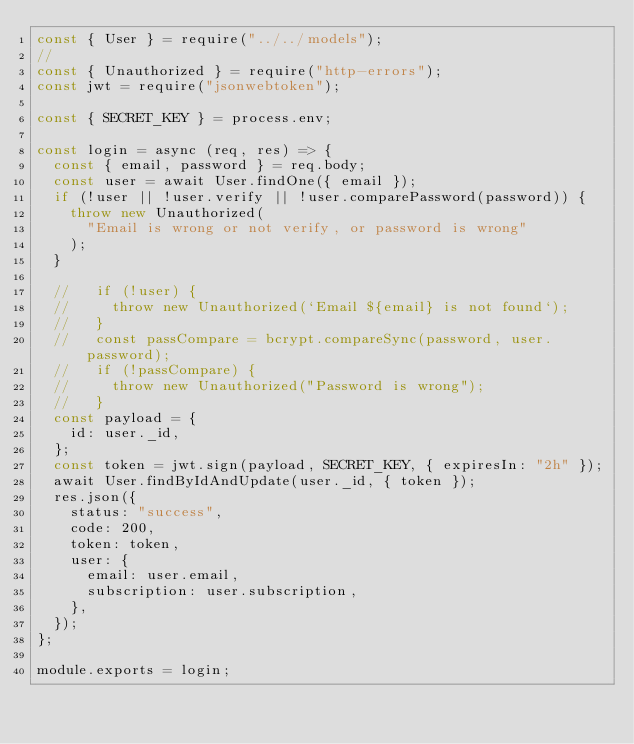Convert code to text. <code><loc_0><loc_0><loc_500><loc_500><_JavaScript_>const { User } = require("../../models");
//
const { Unauthorized } = require("http-errors");
const jwt = require("jsonwebtoken");

const { SECRET_KEY } = process.env;

const login = async (req, res) => {
  const { email, password } = req.body;
  const user = await User.findOne({ email });
  if (!user || !user.verify || !user.comparePassword(password)) {
    throw new Unauthorized(
      "Email is wrong or not verify, or password is wrong"
    );
  }

  //   if (!user) {
  //     throw new Unauthorized(`Email ${email} is not found`);
  //   }
  //   const passCompare = bcrypt.compareSync(password, user.password);
  //   if (!passCompare) {
  //     throw new Unauthorized("Password is wrong");
  //   }
  const payload = {
    id: user._id,
  };
  const token = jwt.sign(payload, SECRET_KEY, { expiresIn: "2h" });
  await User.findByIdAndUpdate(user._id, { token });
  res.json({
    status: "success",
    code: 200,
    token: token,
    user: {
      email: user.email,
      subscription: user.subscription,
    },
  });
};

module.exports = login;
</code> 